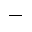<formula> <loc_0><loc_0><loc_500><loc_500>-</formula> 